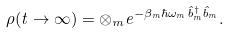<formula> <loc_0><loc_0><loc_500><loc_500>\rho ( t \to \infty ) = \otimes _ { m } e ^ { - \beta _ { m } \hbar { \omega } _ { m } \hat { b } ^ { \dagger } _ { m } \hat { b } _ { m } } .</formula> 